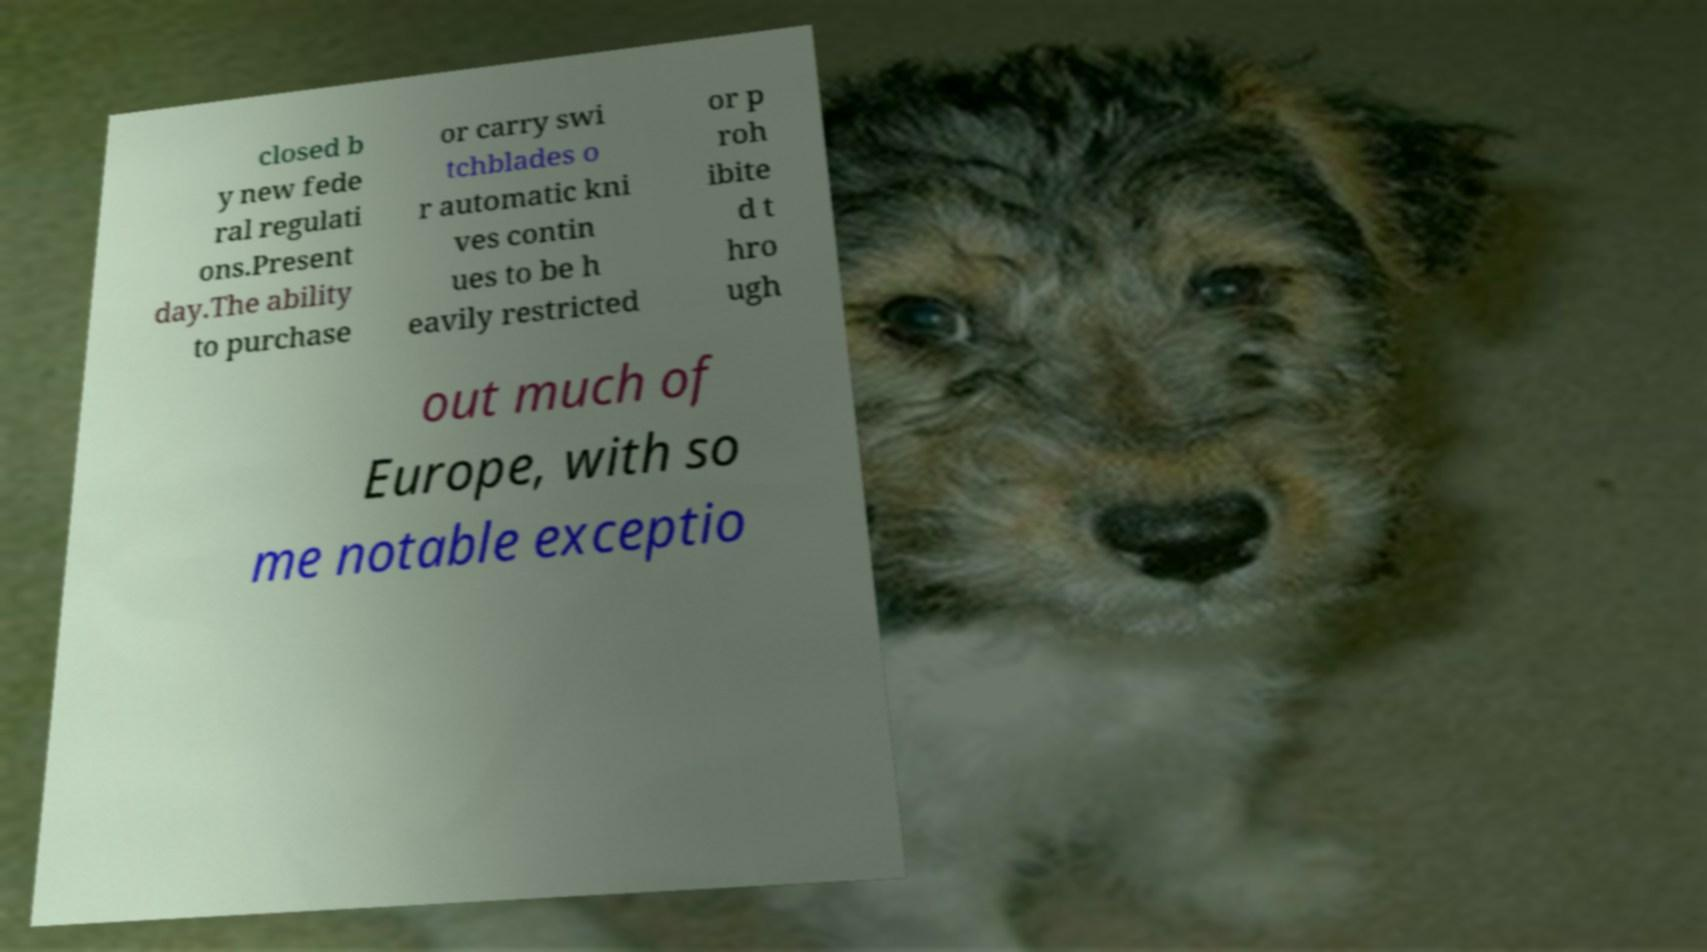Please read and relay the text visible in this image. What does it say? closed b y new fede ral regulati ons.Present day.The ability to purchase or carry swi tchblades o r automatic kni ves contin ues to be h eavily restricted or p roh ibite d t hro ugh out much of Europe, with so me notable exceptio 